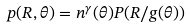<formula> <loc_0><loc_0><loc_500><loc_500>p ( R , \theta ) = n ^ { \gamma } ( \theta ) P ( R / g ( \theta ) )</formula> 